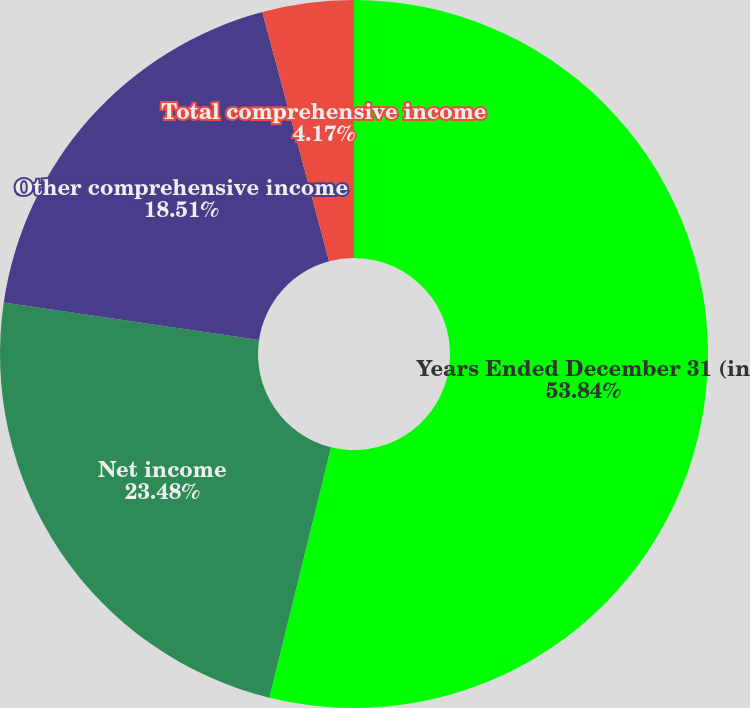Convert chart to OTSL. <chart><loc_0><loc_0><loc_500><loc_500><pie_chart><fcel>Years Ended December 31 (in<fcel>Net income<fcel>Other comprehensive income<fcel>Total comprehensive income<nl><fcel>53.85%<fcel>23.48%<fcel>18.51%<fcel>4.17%<nl></chart> 